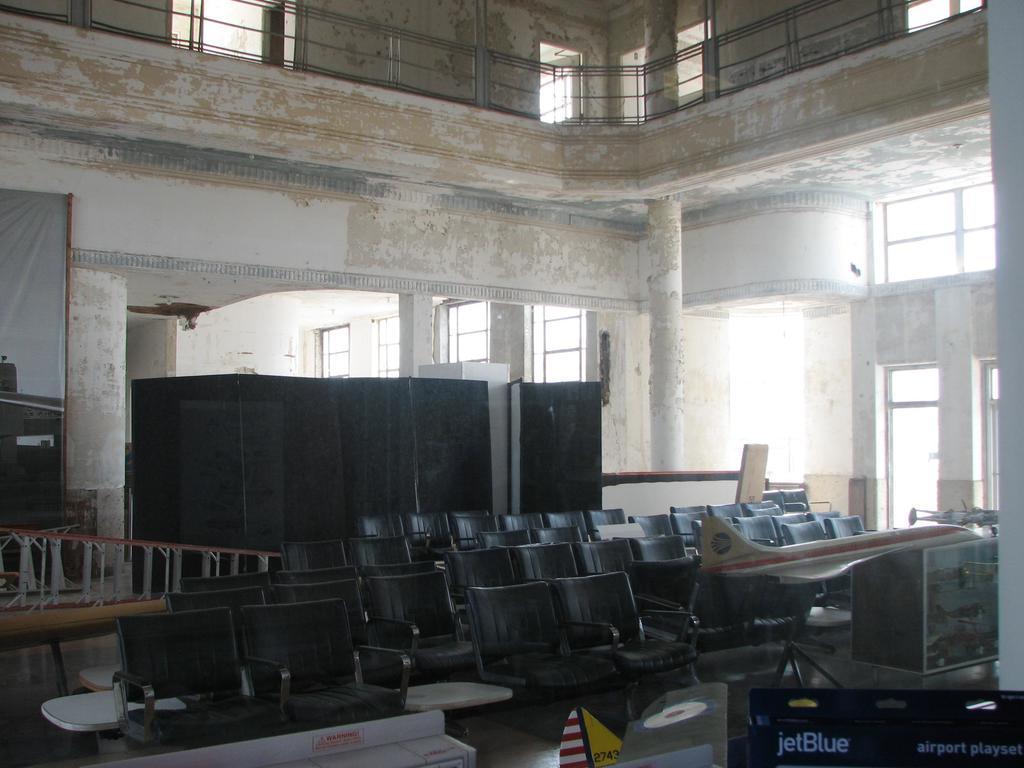Can you describe this image briefly? This is an inside view of a building, where there are windows, iron grills, chairs , a demo airplane, tables. 